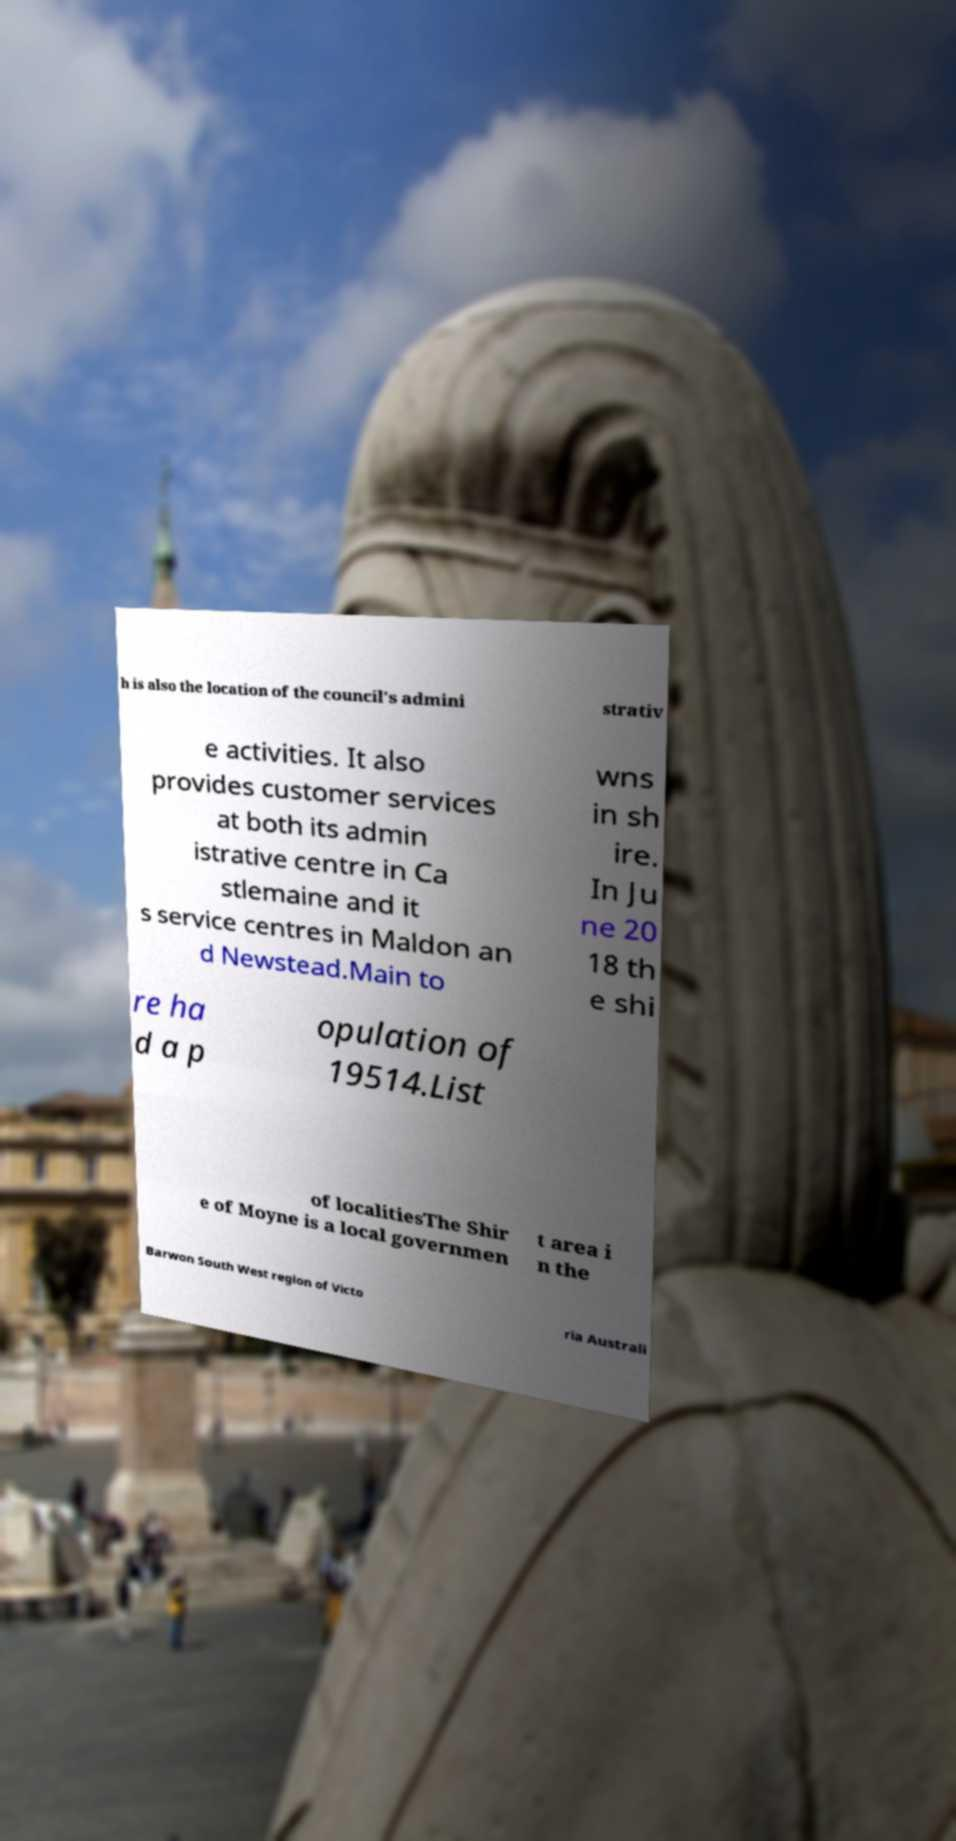I need the written content from this picture converted into text. Can you do that? h is also the location of the council's admini strativ e activities. It also provides customer services at both its admin istrative centre in Ca stlemaine and it s service centres in Maldon an d Newstead.Main to wns in sh ire. In Ju ne 20 18 th e shi re ha d a p opulation of 19514.List of localitiesThe Shir e of Moyne is a local governmen t area i n the Barwon South West region of Victo ria Australi 